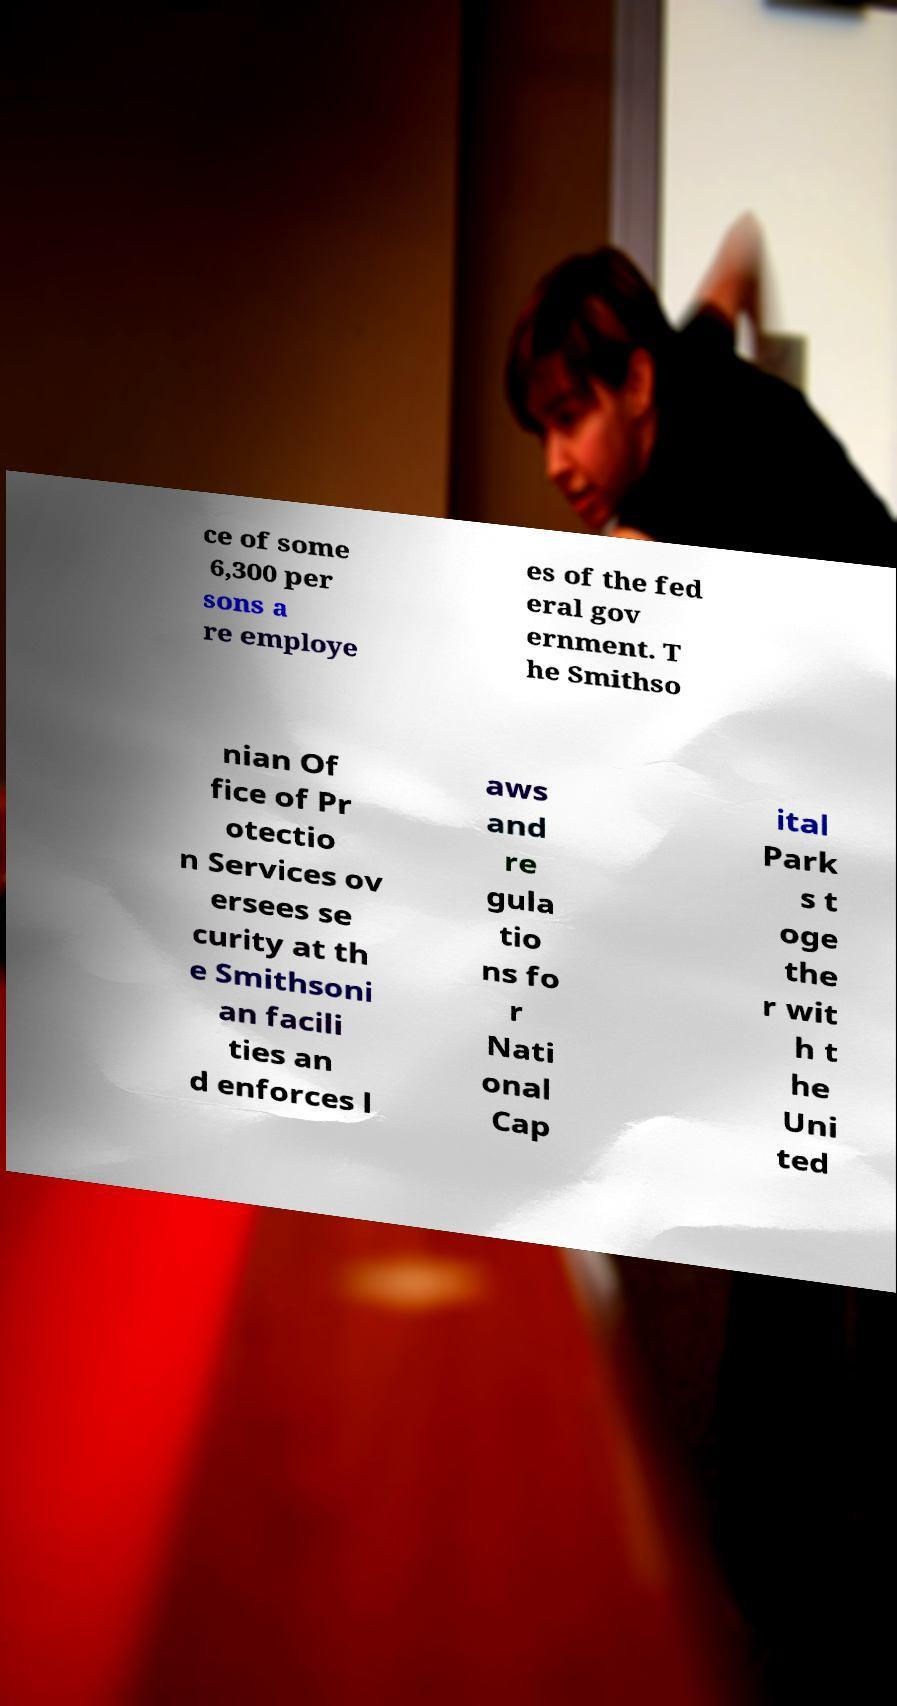Can you accurately transcribe the text from the provided image for me? ce of some 6,300 per sons a re employe es of the fed eral gov ernment. T he Smithso nian Of fice of Pr otectio n Services ov ersees se curity at th e Smithsoni an facili ties an d enforces l aws and re gula tio ns fo r Nati onal Cap ital Park s t oge the r wit h t he Uni ted 